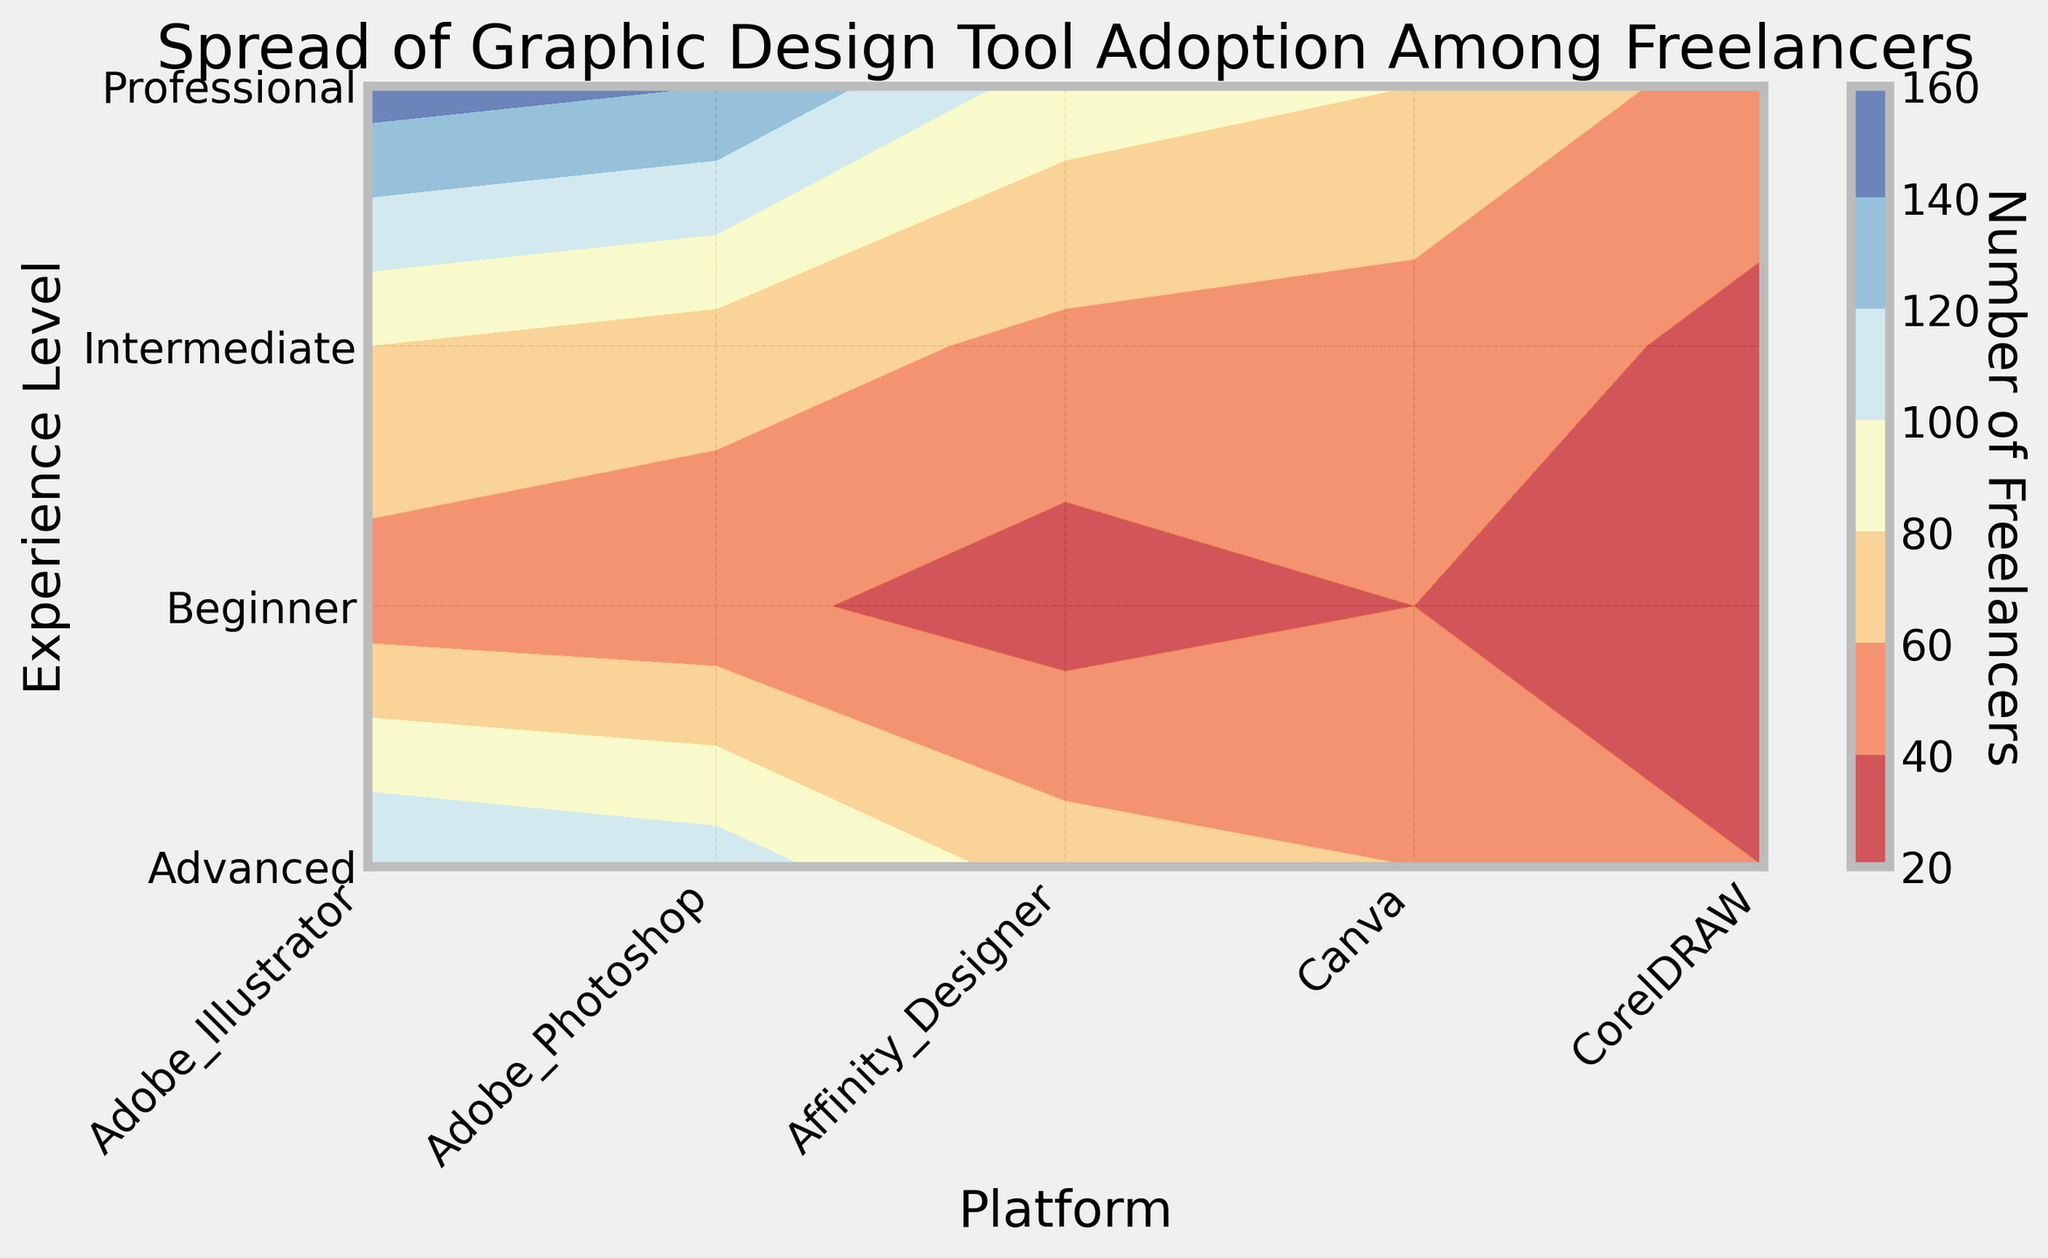Which platform is the most popular among professional freelancers? Look at the darkest colored region at the "Professional" experience level, which corresponds to the highest number of freelancers. The deepest color for the "Professional" level is over "Adobe Illustrator".
Answer: Adobe Illustrator Which platform has the least number of freelancers at the Beginner level? Note the lightest colored region at the "Beginner" experience level. The lightest color corresponds to the lowest number of freelancers, which is "CorelDRAW".
Answer: CorelDRAW How does the popularity of Affinity Designer compare between Intermediate and Advanced freelancers? Compare the color intensity in the "Affinity Designer" column between the "Intermediate" and "Advanced" rows. The Advanced level appears to have a deeper color indicating a higher number of freelancers compared to Intermediate.
Answer: More popular among Advanced freelancers What is the sum of freelancers using Adobe Photoshop across all experience levels? Sum the number of freelancers using Adobe Photoshop for each experience level: 45 (Beginner) + 70 (Intermediate) + 110 (Advanced) + 140 (Professional) = 365.
Answer: 365 Which experience level uses Canva the most? Compare the color intensity for "Canva" across different experience levels. The deepest color for Canva is found in the "Professional" row.
Answer: Professional Which platform shows the smallest difference in popularity between Intermediate and Professional freelancers? Calculate the absolute differences for each platform: Adobe Illustrator (150-80=70), Adobe Photoshop (140-70=70), Affinity Designer (90-55=35), Canva (80-50=30), CorelDRAW (50-35=15). CorelDRAW has the smallest difference of 15.
Answer: CorelDRAW Between Intermediate and Advanced experience levels, which platform shows the greatest increase in the number of freelancers? Calculate the differences for each platform between Intermediate and Advanced: Adobe Illustrator (120-80=40), Adobe Photoshop (110-70=40), Affinity Designer (70-55=15), Canva (60-50=10), CorelDRAW (40-35=5). The platforms having the greatest increase of 40 are Adobe Illustrator and Adobe Photoshop.
Answer: Adobe Illustrator and Adobe Photoshop What is the average number of freelancers using Adobe Illustrator across all experience levels? Calculate the average: (Beginner: 50 + Intermediate: 80 + Advanced: 120 + Professional: 150) / 4 = 400 / 4 = 100.
Answer: 100 